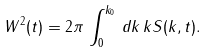<formula> <loc_0><loc_0><loc_500><loc_500>W ^ { 2 } ( t ) = 2 \pi \, \int _ { 0 } ^ { k _ { 0 } } \, d k \, k S ( k , t ) .</formula> 